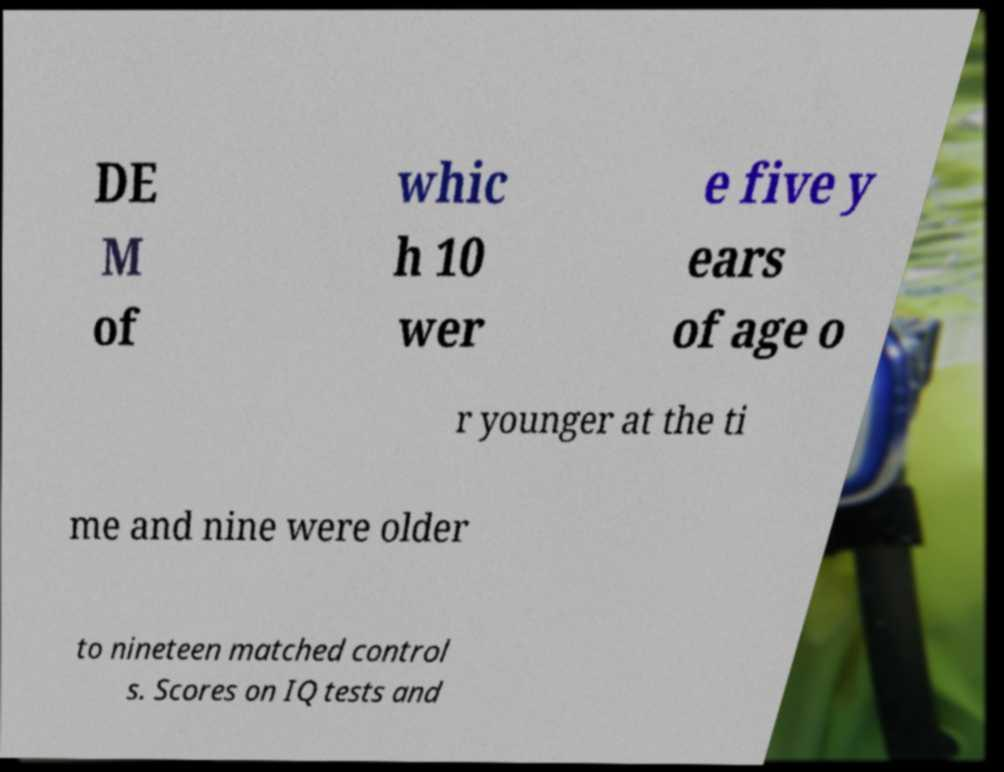There's text embedded in this image that I need extracted. Can you transcribe it verbatim? DE M of whic h 10 wer e five y ears of age o r younger at the ti me and nine were older to nineteen matched control s. Scores on IQ tests and 